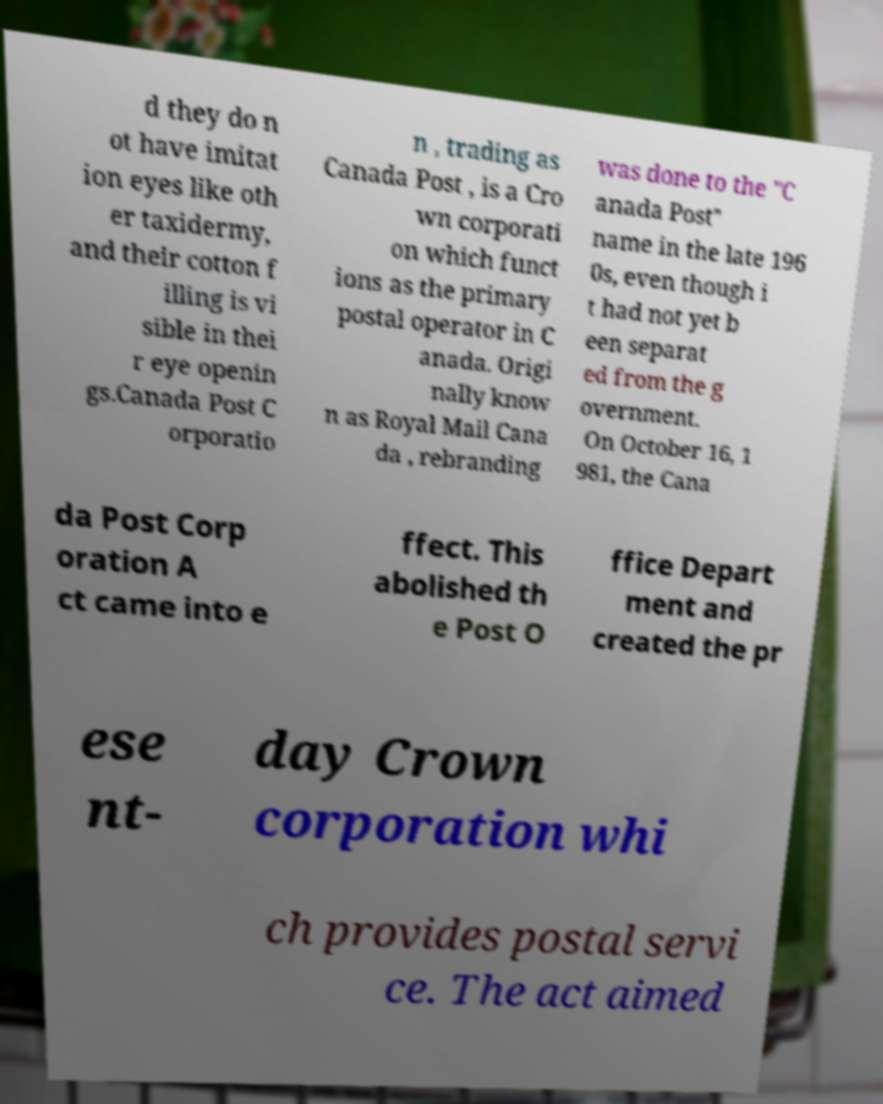Please read and relay the text visible in this image. What does it say? d they do n ot have imitat ion eyes like oth er taxidermy, and their cotton f illing is vi sible in thei r eye openin gs.Canada Post C orporatio n , trading as Canada Post , is a Cro wn corporati on which funct ions as the primary postal operator in C anada. Origi nally know n as Royal Mail Cana da , rebranding was done to the "C anada Post" name in the late 196 0s, even though i t had not yet b een separat ed from the g overnment. On October 16, 1 981, the Cana da Post Corp oration A ct came into e ffect. This abolished th e Post O ffice Depart ment and created the pr ese nt- day Crown corporation whi ch provides postal servi ce. The act aimed 